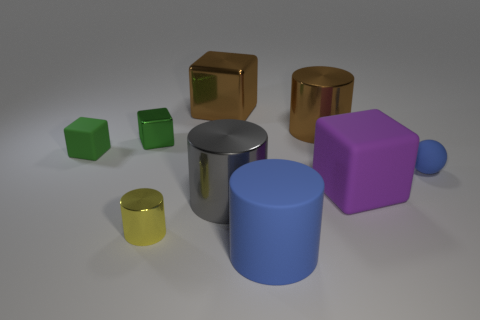What is the size of the thing that is the same color as the rubber ball?
Provide a succinct answer. Large. There is a thing on the left side of the tiny green metal cube; is it the same color as the tiny shiny thing that is behind the purple matte object?
Ensure brevity in your answer.  Yes. What shape is the tiny thing that is the same color as the small metal block?
Your answer should be very brief. Cube. Is there a green metallic object that has the same size as the brown cylinder?
Offer a very short reply. No. What number of rubber balls are behind the large brown thing in front of the brown block?
Make the answer very short. 0. What material is the tiny blue ball?
Your response must be concise. Rubber. There is a large gray object; how many large purple things are in front of it?
Give a very brief answer. 0. Is the color of the tiny sphere the same as the tiny metallic cube?
Provide a short and direct response. No. What number of tiny metallic objects are the same color as the large matte cylinder?
Your response must be concise. 0. Are there more tiny blue shiny cylinders than tiny green rubber objects?
Offer a terse response. No. 